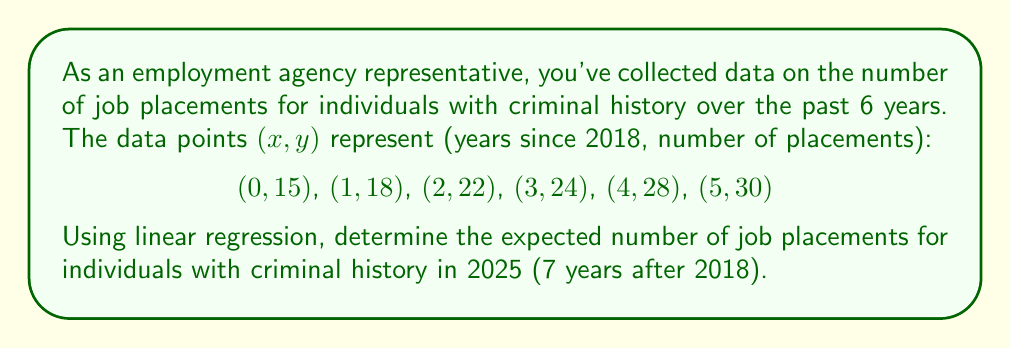Help me with this question. To solve this problem using linear regression, we'll follow these steps:

1. Calculate the means of x and y:
   $\bar{x} = \frac{0 + 1 + 2 + 3 + 4 + 5}{6} = 2.5$
   $\bar{y} = \frac{15 + 18 + 22 + 24 + 28 + 30}{6} = 22.8333$

2. Calculate the slope (m) using the formula:
   $$m = \frac{\sum(x_i - \bar{x})(y_i - \bar{y})}{\sum(x_i - \bar{x})^2}$$

   $\sum(x_i - \bar{x})(y_i - \bar{y}) = (-2.5)(15-22.8333) + (-1.5)(18-22.8333) + ...$
                                        $= 70.8333$
   
   $\sum(x_i - \bar{x})^2 = (-2.5)^2 + (-1.5)^2 + ...= 17.5$

   $m = \frac{70.8333}{17.5} = 4.0476$

3. Calculate the y-intercept (b) using the formula:
   $b = \bar{y} - m\bar{x} = 22.8333 - 4.0476(2.5) = 12.7143$

4. The linear regression equation is:
   $y = mx + b = 4.0476x + 12.7143$

5. To predict the number of placements in 2025, we substitute x = 7:
   $y = 4.0476(7) + 12.7143 = 41.0475$

6. Round to the nearest whole number as we're dealing with job placements.
Answer: 41 job placements 